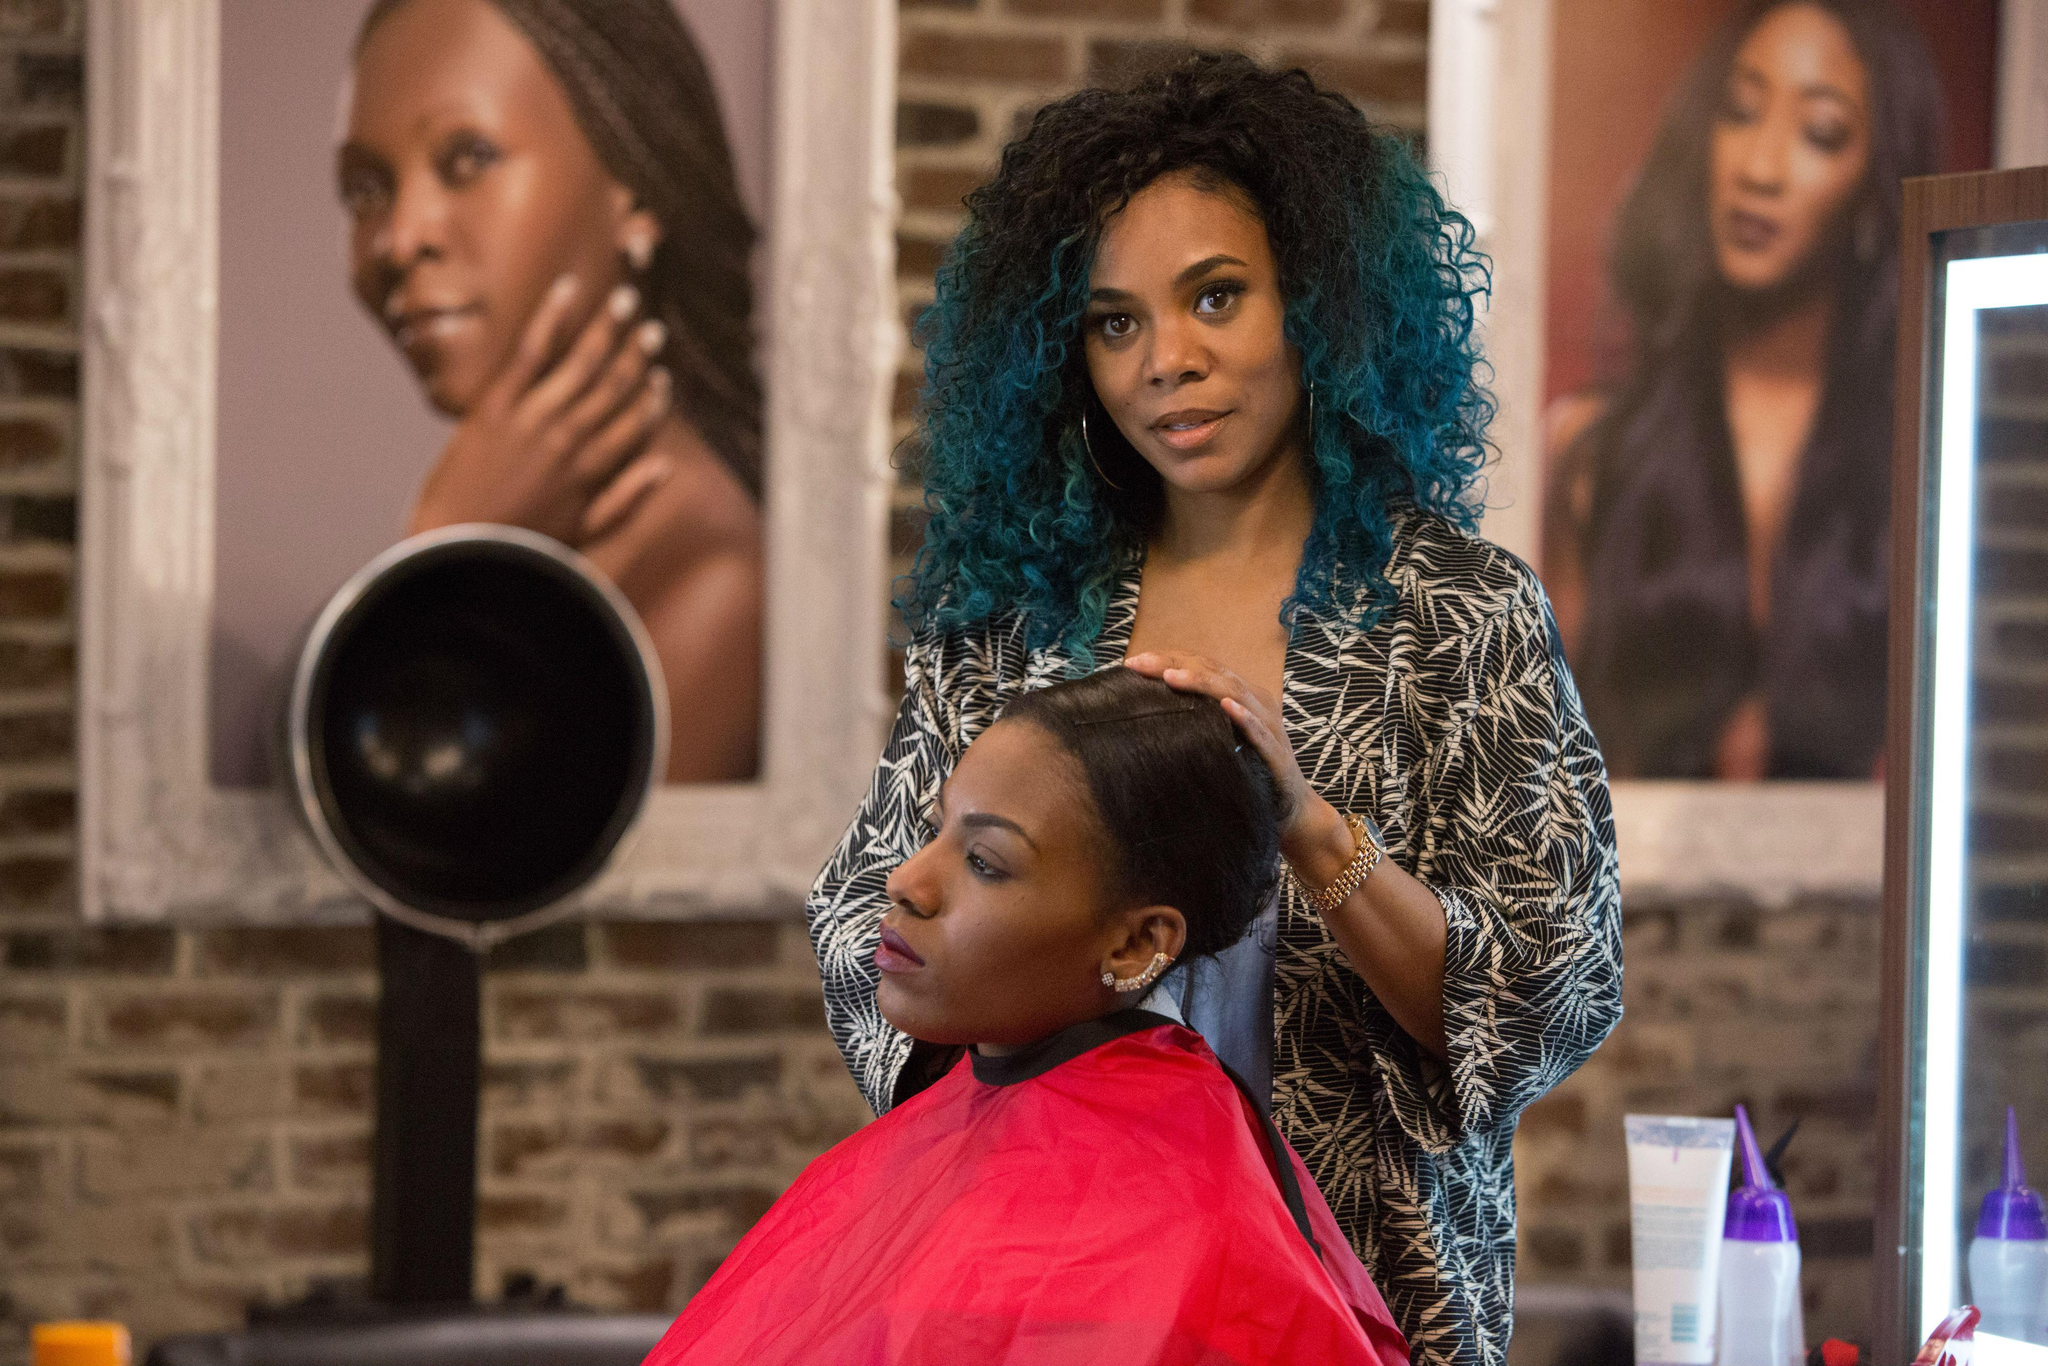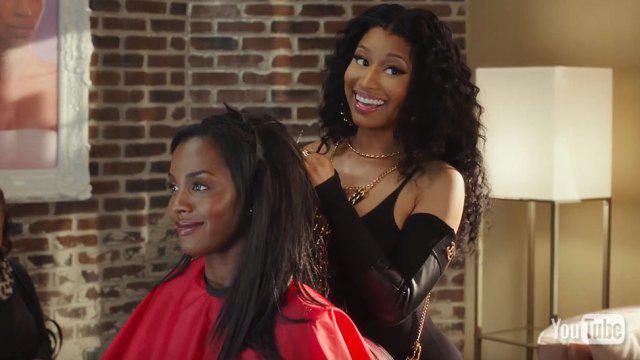The first image is the image on the left, the second image is the image on the right. For the images displayed, is the sentence "None of the women in the pictures have blue hair." factually correct? Answer yes or no. No. The first image is the image on the left, the second image is the image on the right. Considering the images on both sides, is "An image shows a woman in a printed top standing behind a customer in a red smock." valid? Answer yes or no. Yes. 